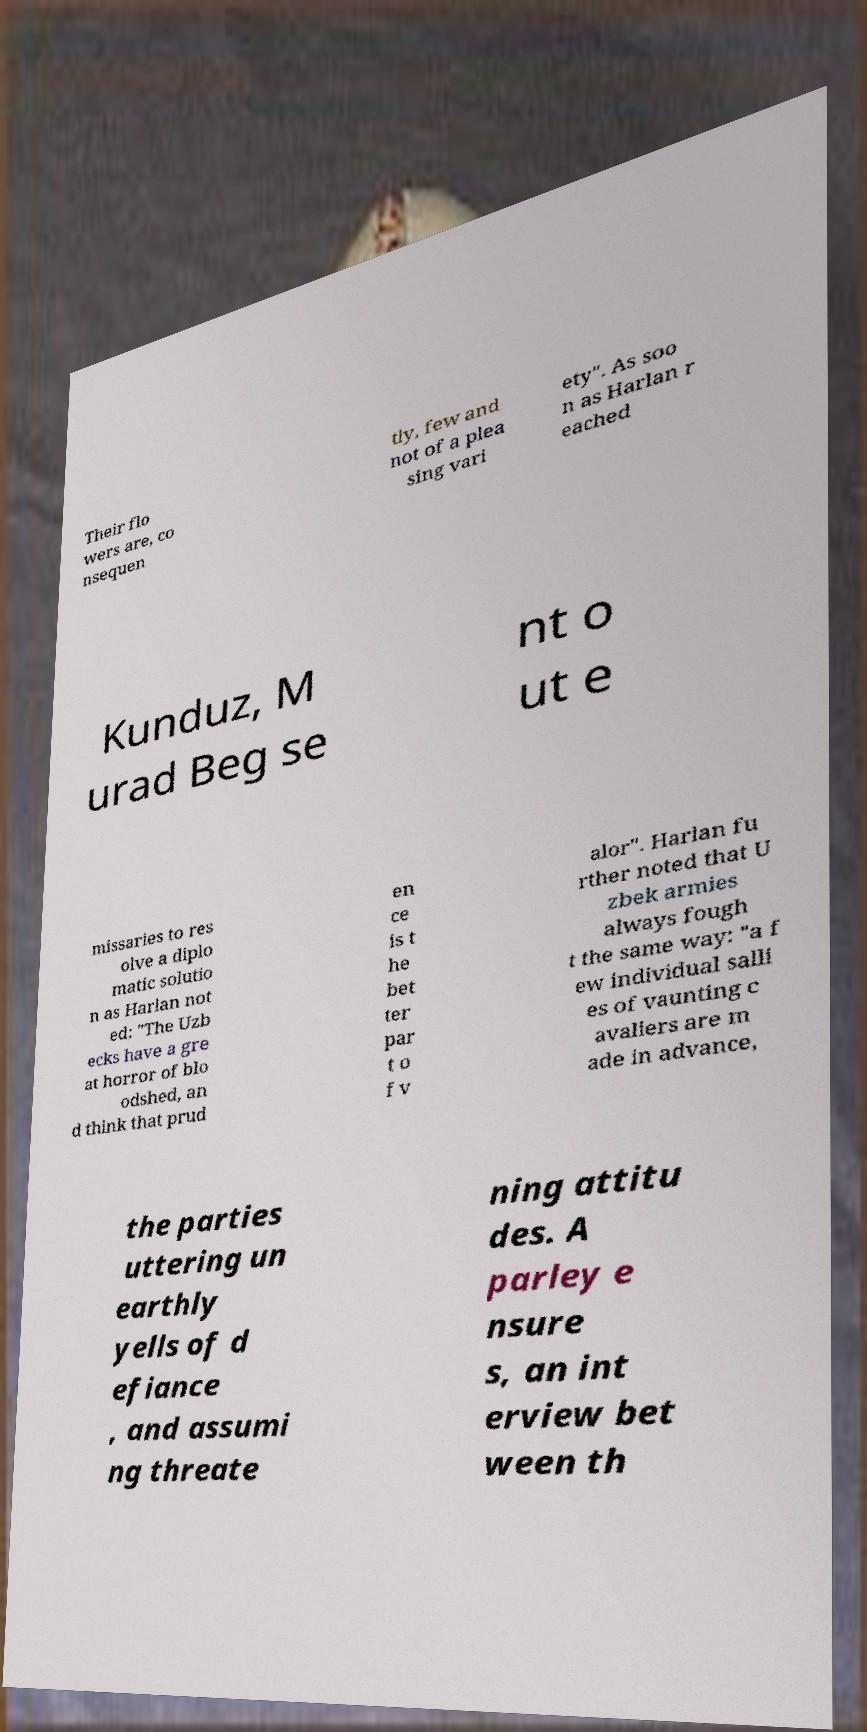For documentation purposes, I need the text within this image transcribed. Could you provide that? Their flo wers are, co nsequen tly, few and not of a plea sing vari ety". As soo n as Harlan r eached Kunduz, M urad Beg se nt o ut e missaries to res olve a diplo matic solutio n as Harlan not ed: "The Uzb ecks have a gre at horror of blo odshed, an d think that prud en ce is t he bet ter par t o f v alor". Harlan fu rther noted that U zbek armies always fough t the same way: "a f ew individual salli es of vaunting c avaliers are m ade in advance, the parties uttering un earthly yells of d efiance , and assumi ng threate ning attitu des. A parley e nsure s, an int erview bet ween th 